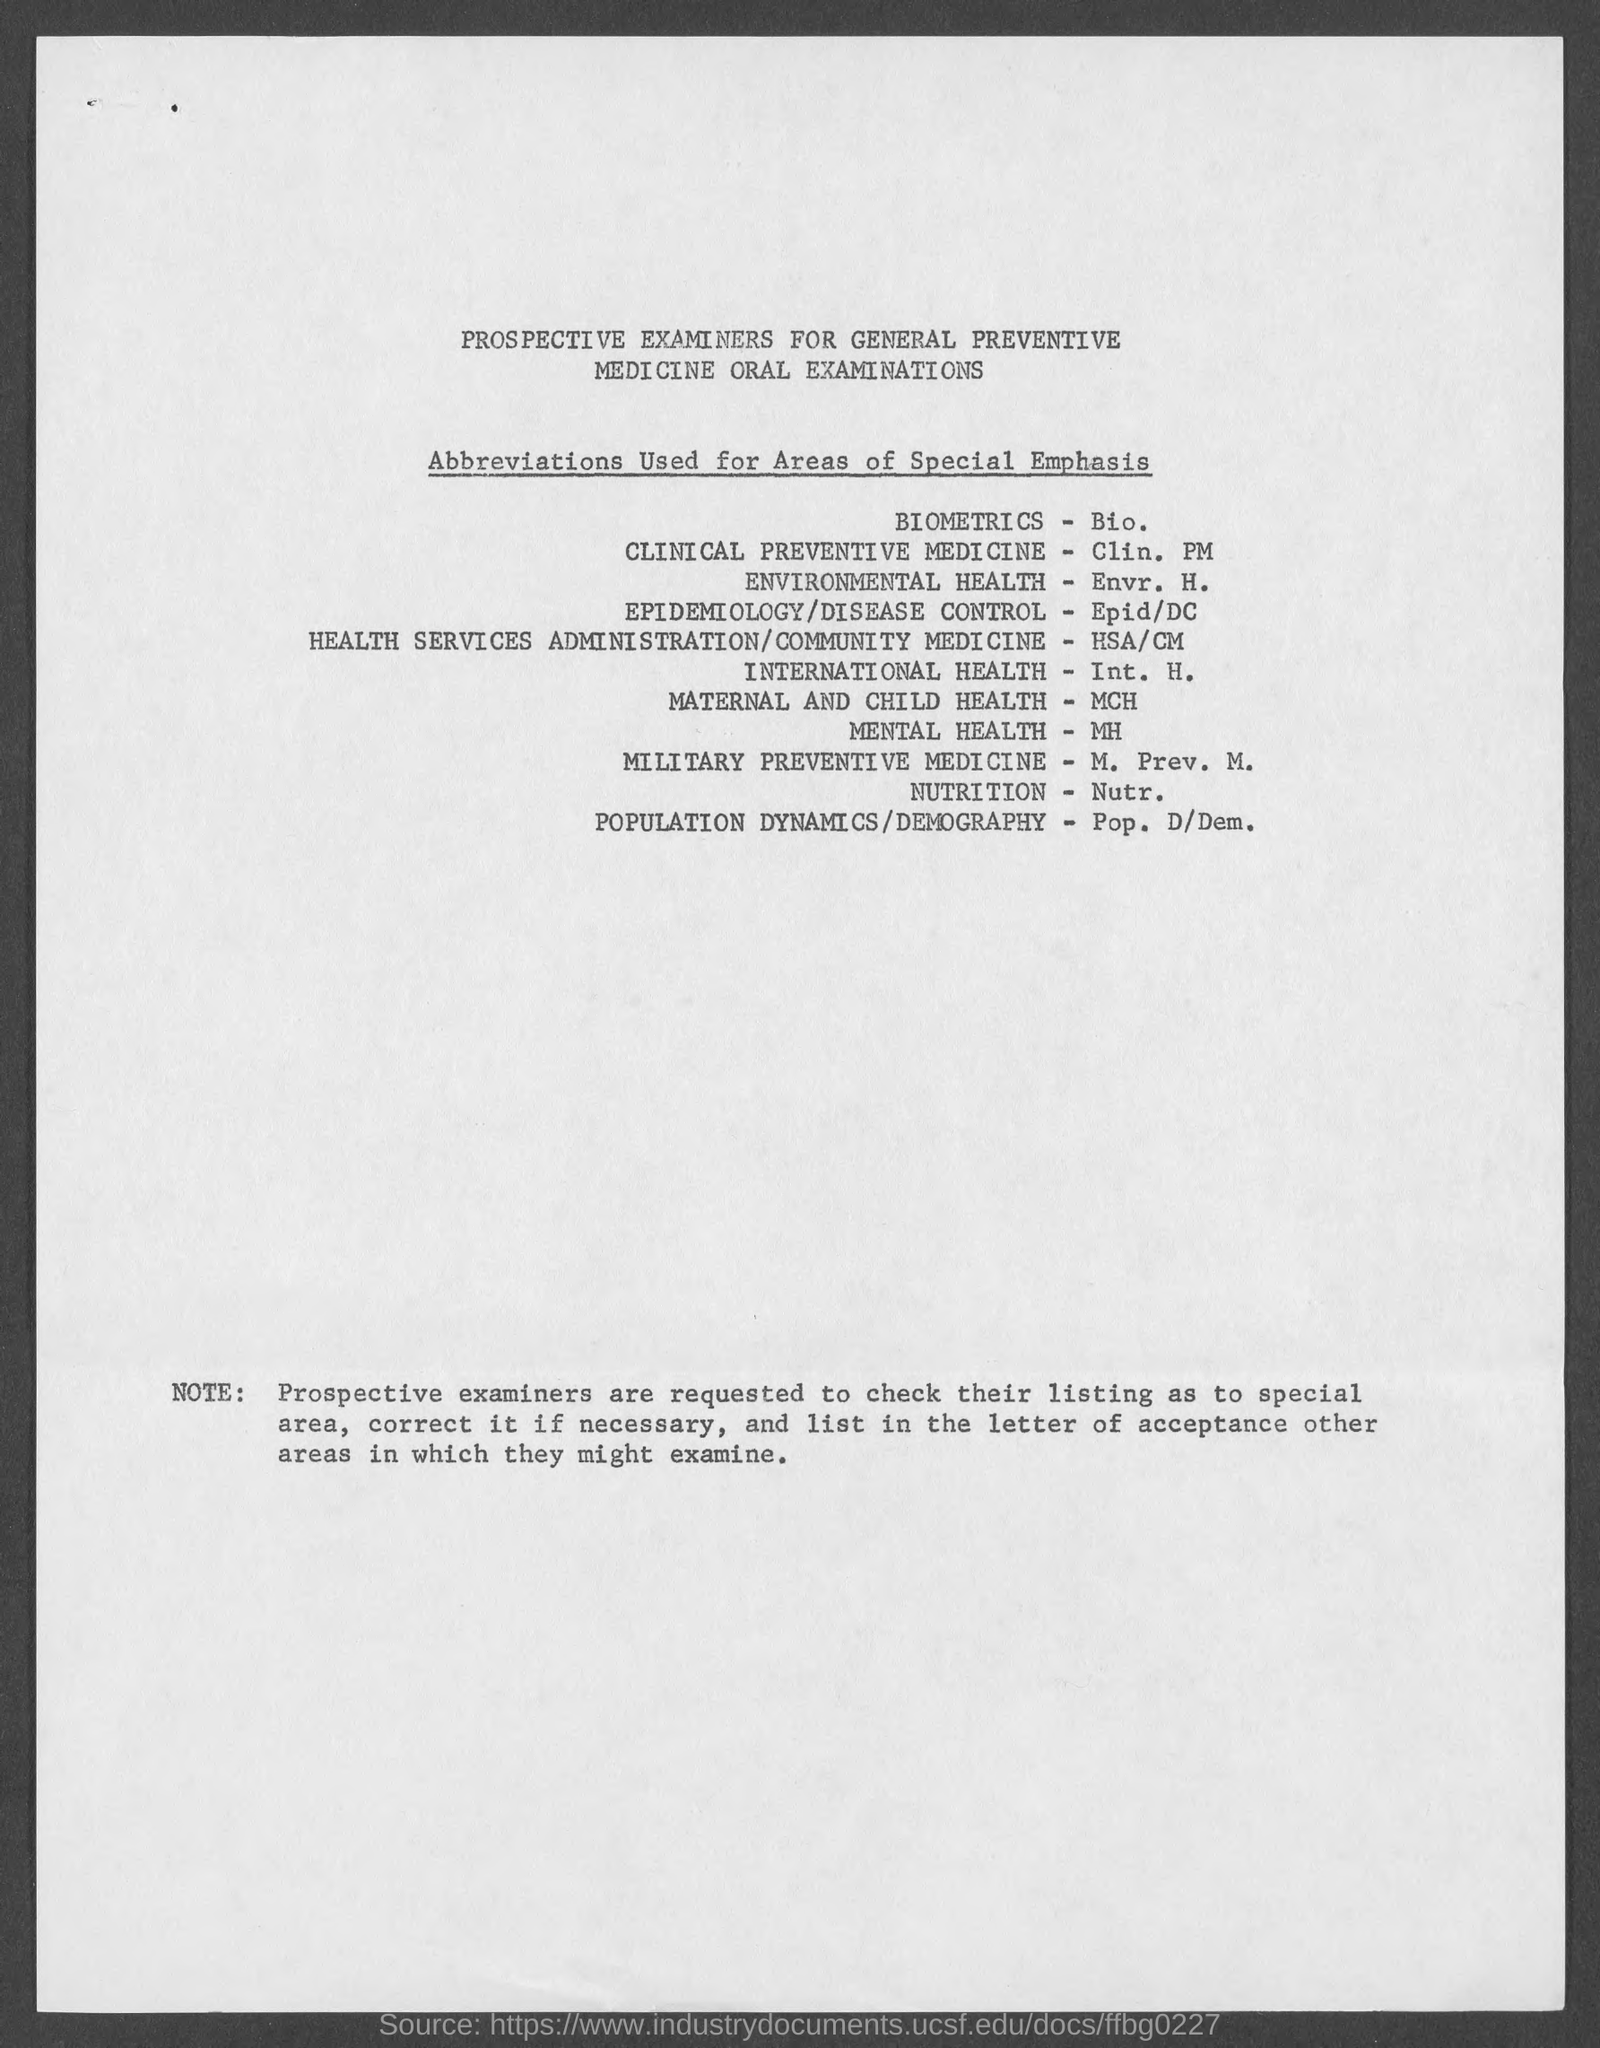What is the abbreviation used for BIOMETRICS?
Give a very brief answer. Bio. What does Clin. PM stand for?
Your answer should be compact. CLINICAL PREVENTIVE MEDICINE. What does Pop. D/Dem denote?
Provide a succinct answer. POPULATION DYNAMICS/DEMOGRAPHY. What is the abbreviation of MILITARY PREVENTIVE MEDICINE?
Provide a succinct answer. M. Prev. M. 